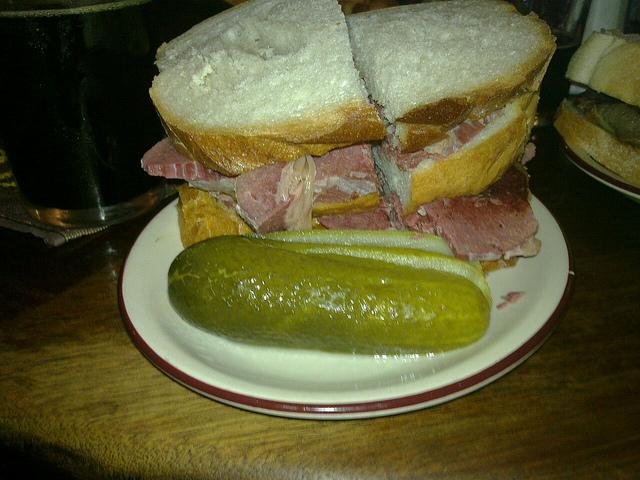What taste does the green food have? sour 